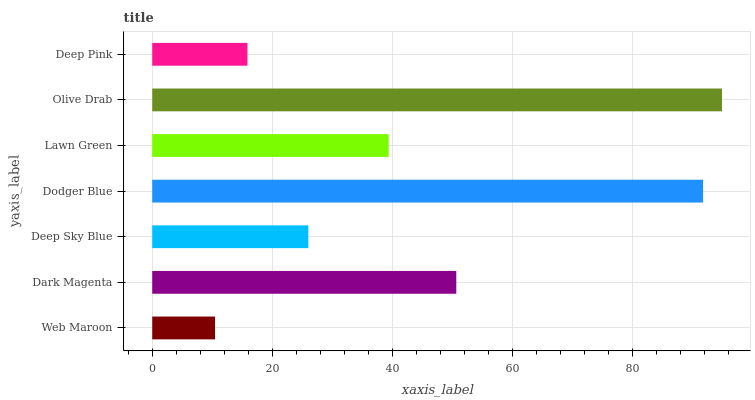Is Web Maroon the minimum?
Answer yes or no. Yes. Is Olive Drab the maximum?
Answer yes or no. Yes. Is Dark Magenta the minimum?
Answer yes or no. No. Is Dark Magenta the maximum?
Answer yes or no. No. Is Dark Magenta greater than Web Maroon?
Answer yes or no. Yes. Is Web Maroon less than Dark Magenta?
Answer yes or no. Yes. Is Web Maroon greater than Dark Magenta?
Answer yes or no. No. Is Dark Magenta less than Web Maroon?
Answer yes or no. No. Is Lawn Green the high median?
Answer yes or no. Yes. Is Lawn Green the low median?
Answer yes or no. Yes. Is Deep Pink the high median?
Answer yes or no. No. Is Dark Magenta the low median?
Answer yes or no. No. 